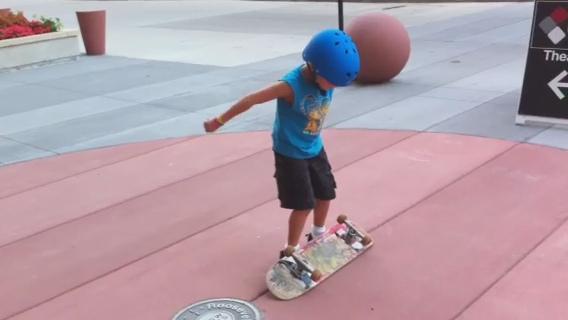What will the child try to do first?
Select the accurate answer and provide explanation: 'Answer: answer
Rationale: rationale.'
Options: Rest, flip board, yell, eat. Answer: flip board.
Rationale: The child is participating in an extreme sport. the four-wheeled object he is using is upside down. 